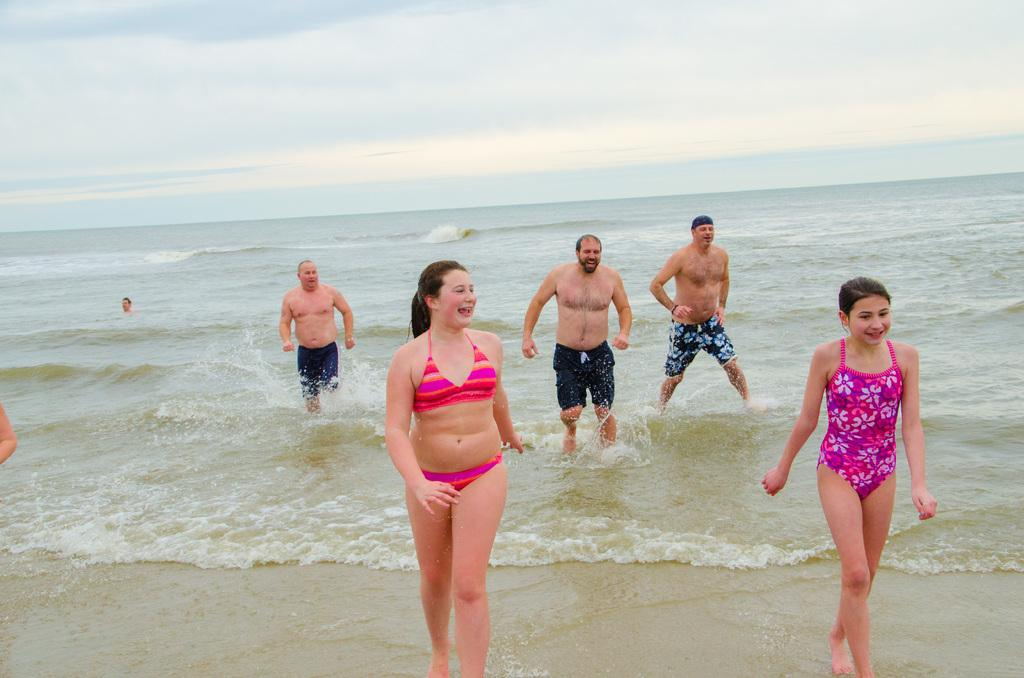Who is present in the image? There are women and men in the image. Where are the people in the image? They are at the beach. What can be seen in the background of the image? There is an ocean in the background of the image. What is visible in the sky in the image? The sky is visible in the image, and there are clouds in the sky. How are the people in the image feeling? The people in the image are smiling. What type of oven is visible in the image? There is no oven present in the image; it is a beach scene with people and an ocean. What is the name of the person standing on the left side of the image? The provided facts do not include any names of the people in the image. 